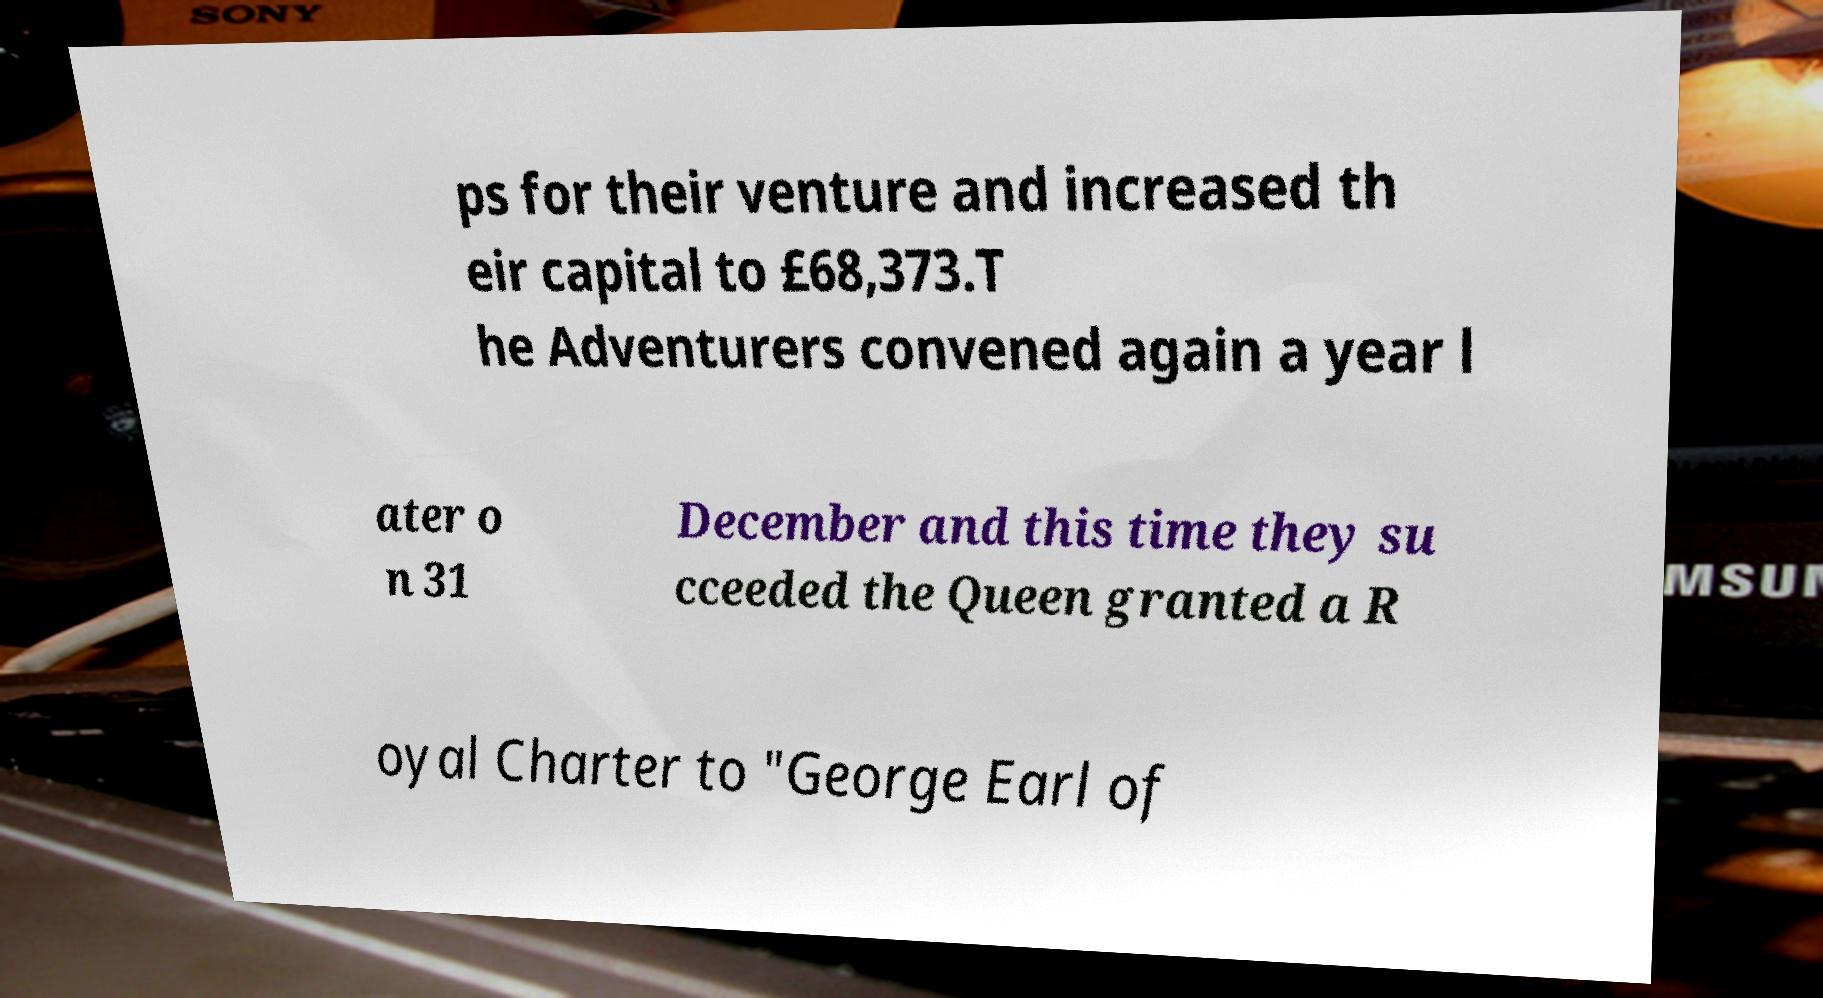I need the written content from this picture converted into text. Can you do that? ps for their venture and increased th eir capital to £68,373.T he Adventurers convened again a year l ater o n 31 December and this time they su cceeded the Queen granted a R oyal Charter to "George Earl of 